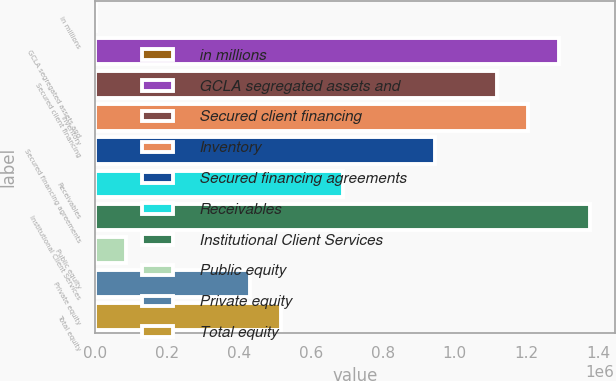Convert chart. <chart><loc_0><loc_0><loc_500><loc_500><bar_chart><fcel>in millions<fcel>GCLA segregated assets and<fcel>Secured client financing<fcel>Inventory<fcel>Secured financing agreements<fcel>Receivables<fcel>Institutional Client Services<fcel>Public equity<fcel>Private equity<fcel>Total equity<nl><fcel>2016<fcel>1.28924e+06<fcel>1.11761e+06<fcel>1.20342e+06<fcel>945980<fcel>688535<fcel>1.37505e+06<fcel>87830.9<fcel>431090<fcel>516905<nl></chart> 